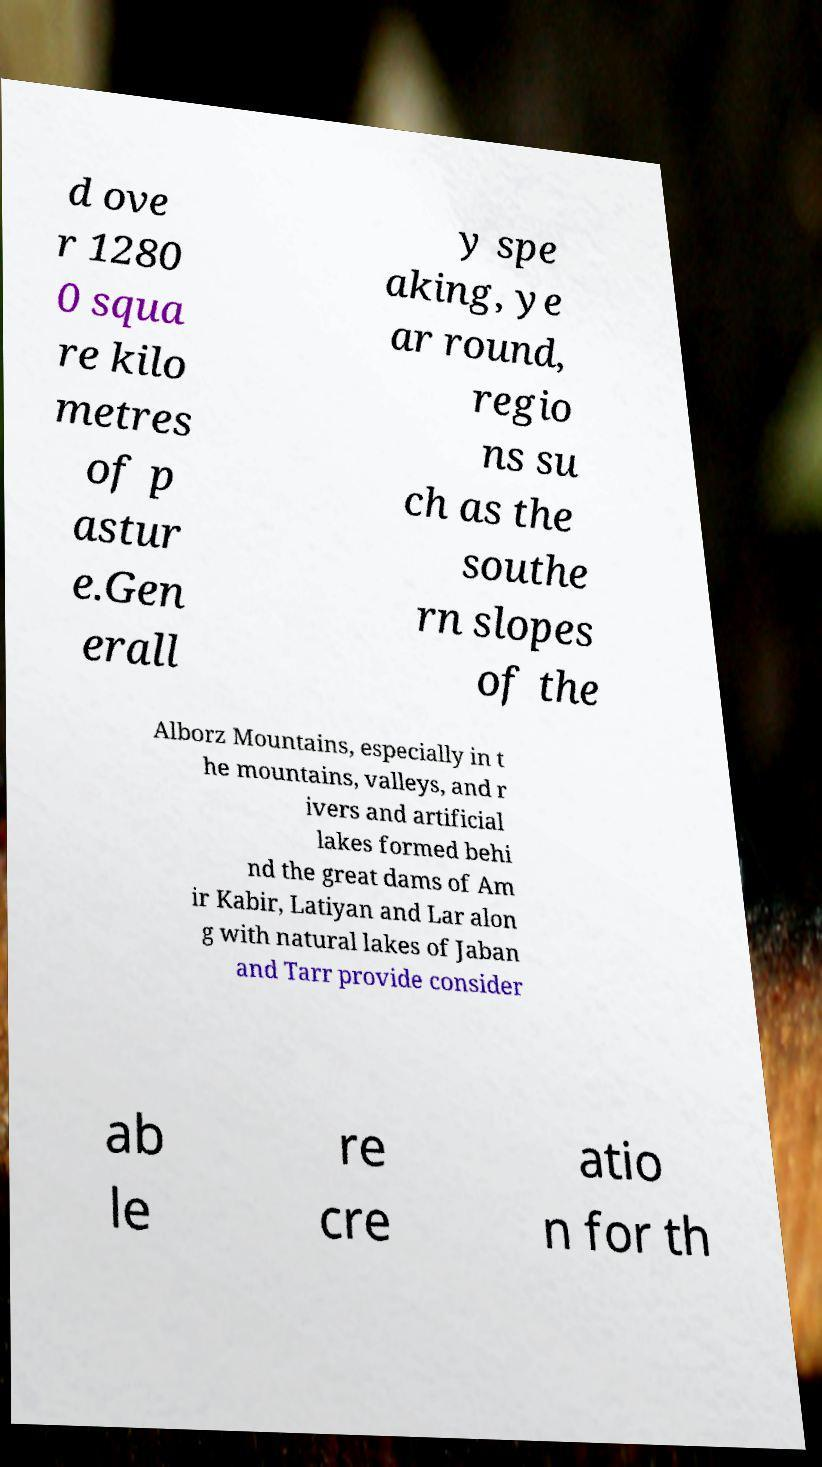There's text embedded in this image that I need extracted. Can you transcribe it verbatim? d ove r 1280 0 squa re kilo metres of p astur e.Gen erall y spe aking, ye ar round, regio ns su ch as the southe rn slopes of the Alborz Mountains, especially in t he mountains, valleys, and r ivers and artificial lakes formed behi nd the great dams of Am ir Kabir, Latiyan and Lar alon g with natural lakes of Jaban and Tarr provide consider ab le re cre atio n for th 